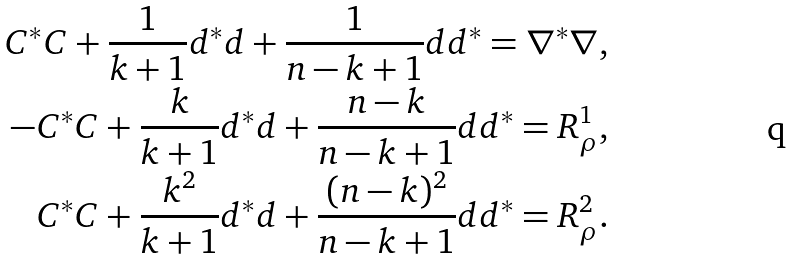<formula> <loc_0><loc_0><loc_500><loc_500>C ^ { \ast } C + \frac { 1 } { k + 1 } d ^ { \ast } d + \frac { 1 } { n - k + 1 } d d ^ { \ast } = \nabla ^ { \ast } \nabla , \\ - C ^ { \ast } C + \frac { k } { k + 1 } d ^ { \ast } d + \frac { n - k } { n - k + 1 } d d ^ { \ast } = R ^ { 1 } _ { \rho } , \\ C ^ { \ast } C + \frac { k ^ { 2 } } { k + 1 } d ^ { \ast } d + \frac { ( n - k ) ^ { 2 } } { n - k + 1 } d d ^ { \ast } = R ^ { 2 } _ { \rho } .</formula> 